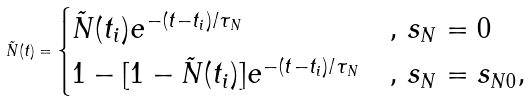<formula> <loc_0><loc_0><loc_500><loc_500>\tilde { N } ( t ) = \begin{cases} \tilde { N } ( t _ { i } ) e ^ { - ( t - t _ { i } ) / \tau _ { N } } & , \, s _ { N } = 0 \\ 1 - [ 1 - \tilde { N } ( t _ { i } ) ] e ^ { - ( t - t _ { i } ) / \tau _ { N } } & , \, s _ { N } = s _ { N 0 } , \end{cases}</formula> 